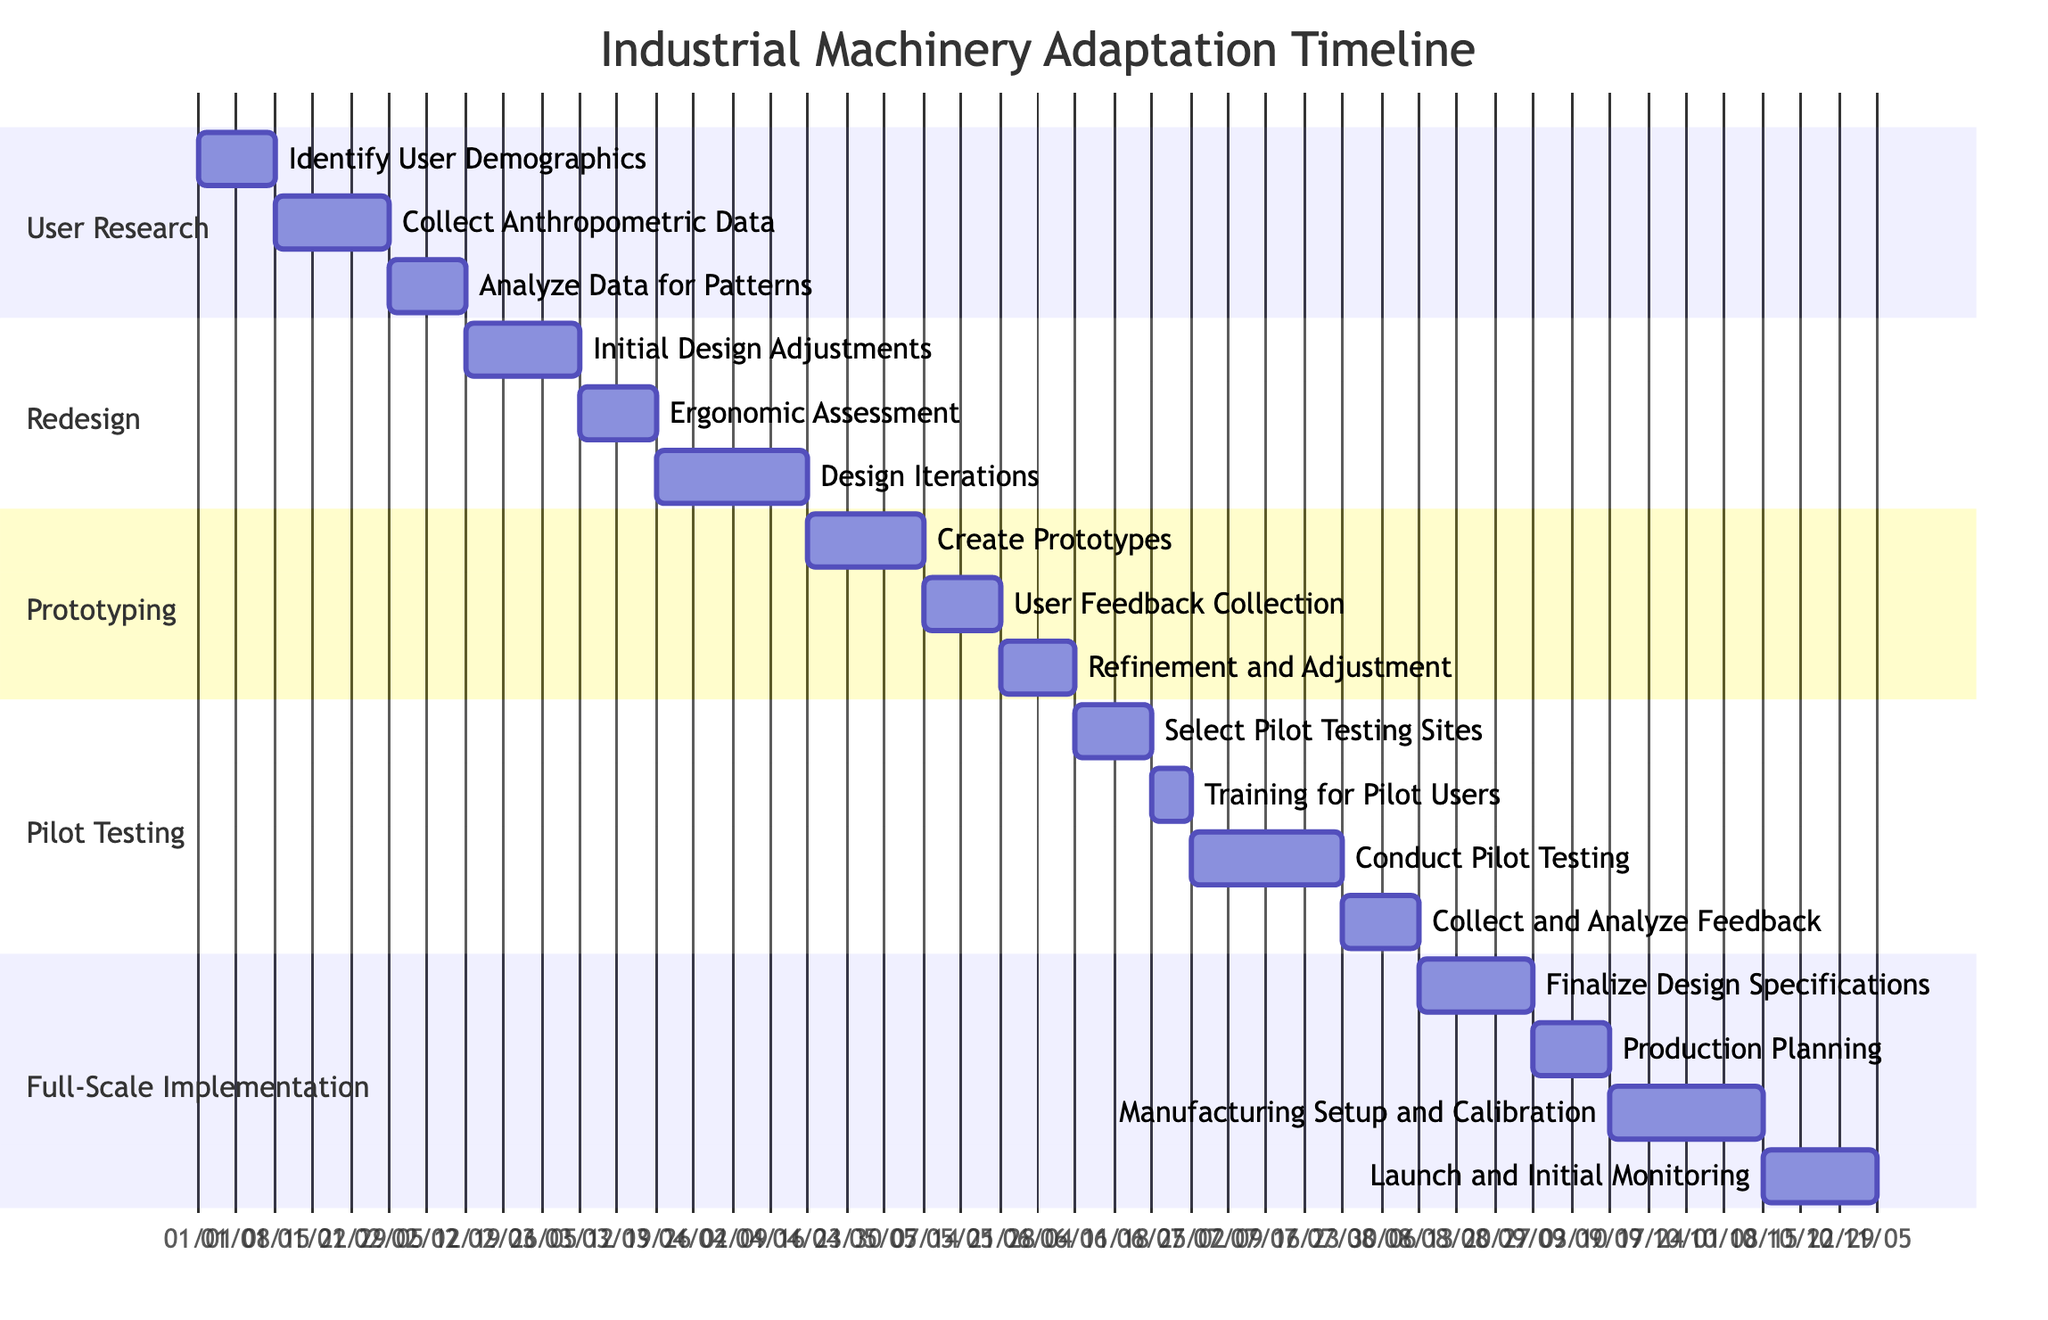What is the duration of the "Collect Anthropometric Data" task? The diagram indicates that "Collect Anthropometric Data" has a duration of 3 weeks, as shown in the time distribution under the "User Research" section.
Answer: 3 weeks Which task follows "Initial Design Adjustments"? By tracing the sequence of tasks in the "Redesign" section, "Ergonomic Assessment" directly follows "Initial Design Adjustments."
Answer: Ergonomic Assessment How many tasks are there in the "Pilot Testing" section? The "Pilot Testing" section lists 4 distinct tasks: "Select Pilot Testing Sites," "Training for Pilot Users," "Conduct Pilot Testing," and "Collect and Analyze Feedback." Counting these gives a total of 4 tasks.
Answer: 4 What is the total duration of the "Full-Scale Implementation" stage? The total duration can be calculated by adding the durations of its tasks: 3 weeks for "Finalize Design Specifications," 2 weeks for "Production Planning," 4 weeks for "Manufacturing Setup and Calibration," and 3 weeks for "Launch and Initial Monitoring," which sums up to 12 weeks.
Answer: 12 weeks What task overlaps with "User Feedback Collection"? "User Feedback Collection" (2 weeks) begins on May 14, 2023, and overlaps with "Refinement and Adjustment," which starts on May 28, 2023, as its duration extends into the first week of "Refinement and Adjustment."
Answer: Refinement and Adjustment What is the end date for the "Conduct Pilot Testing" task? The task "Conduct Pilot Testing" starts on July 2, 2023, and runs for 4 weeks, concluding on July 30, 2023 which can be verified by counting the duration from the start date.
Answer: July 30, 2023 